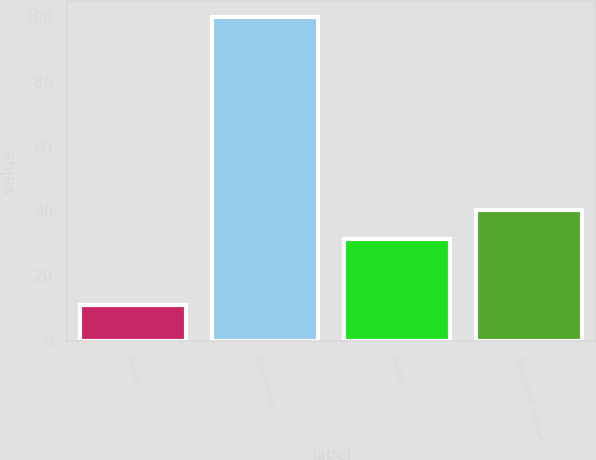Convert chart. <chart><loc_0><loc_0><loc_500><loc_500><bar_chart><fcel>Service<fcel>Total revenue<fcel>Product<fcel>Total cost of revenue<nl><fcel>11.1<fcel>100<fcel>31.5<fcel>40.39<nl></chart> 